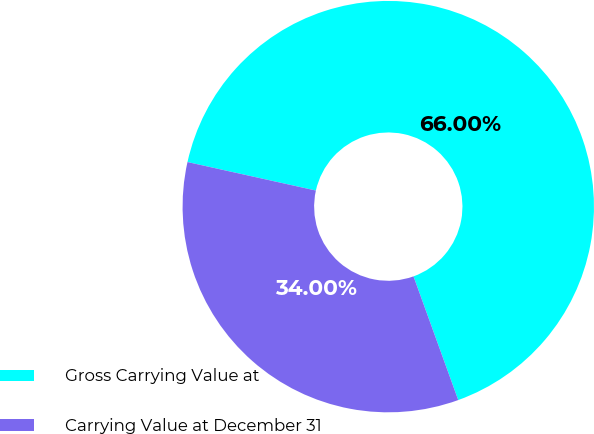Convert chart. <chart><loc_0><loc_0><loc_500><loc_500><pie_chart><fcel>Gross Carrying Value at<fcel>Carrying Value at December 31<nl><fcel>66.0%<fcel>34.0%<nl></chart> 